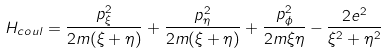<formula> <loc_0><loc_0><loc_500><loc_500>H _ { c o u l } = \frac { p ^ { 2 } _ { \xi } } { 2 m ( \xi + \eta ) } + \frac { p ^ { 2 } _ { \eta } } { 2 m ( \xi + \eta ) } + \frac { p ^ { 2 } _ { \phi } } { 2 m \xi \eta } - \frac { 2 e ^ { 2 } } { \xi ^ { 2 } + \eta ^ { 2 } }</formula> 